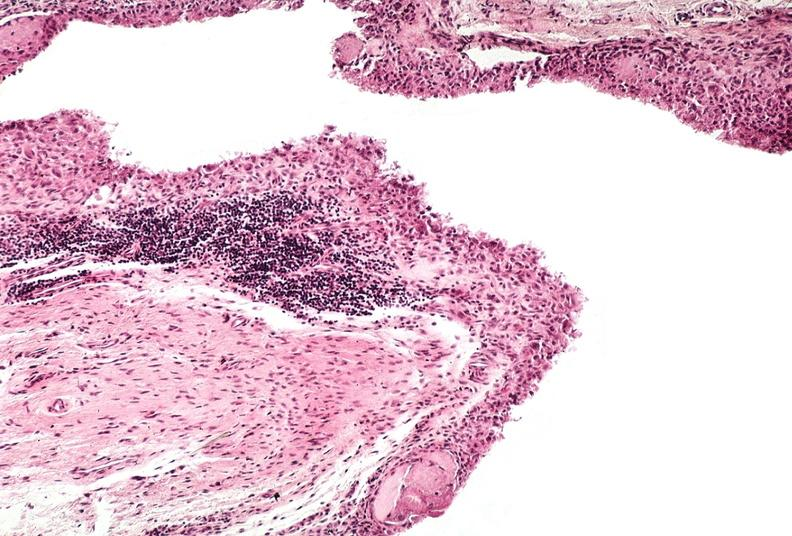what is present?
Answer the question using a single word or phrase. Joints 